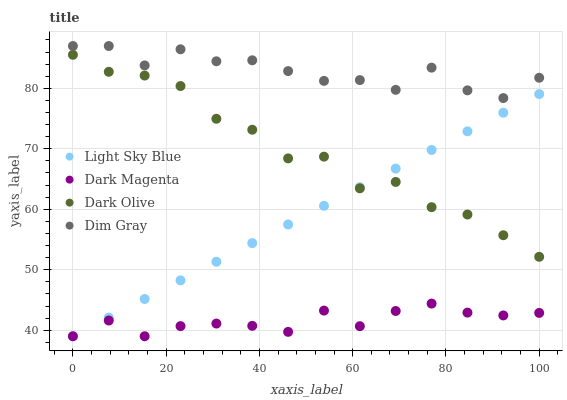Does Dark Magenta have the minimum area under the curve?
Answer yes or no. Yes. Does Dim Gray have the maximum area under the curve?
Answer yes or no. Yes. Does Light Sky Blue have the minimum area under the curve?
Answer yes or no. No. Does Light Sky Blue have the maximum area under the curve?
Answer yes or no. No. Is Light Sky Blue the smoothest?
Answer yes or no. Yes. Is Dim Gray the roughest?
Answer yes or no. Yes. Is Dim Gray the smoothest?
Answer yes or no. No. Is Light Sky Blue the roughest?
Answer yes or no. No. Does Light Sky Blue have the lowest value?
Answer yes or no. Yes. Does Dim Gray have the lowest value?
Answer yes or no. No. Does Dim Gray have the highest value?
Answer yes or no. Yes. Does Light Sky Blue have the highest value?
Answer yes or no. No. Is Light Sky Blue less than Dim Gray?
Answer yes or no. Yes. Is Dim Gray greater than Dark Olive?
Answer yes or no. Yes. Does Dark Olive intersect Light Sky Blue?
Answer yes or no. Yes. Is Dark Olive less than Light Sky Blue?
Answer yes or no. No. Is Dark Olive greater than Light Sky Blue?
Answer yes or no. No. Does Light Sky Blue intersect Dim Gray?
Answer yes or no. No. 